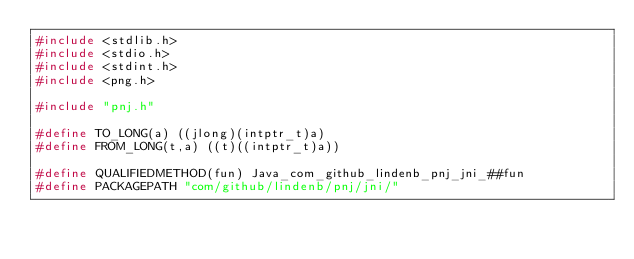Convert code to text. <code><loc_0><loc_0><loc_500><loc_500><_C_>#include <stdlib.h>
#include <stdio.h>
#include <stdint.h>
#include <png.h>

#include "pnj.h"

#define TO_LONG(a) ((jlong)(intptr_t)a)
#define FROM_LONG(t,a) ((t)((intptr_t)a)) 

#define QUALIFIEDMETHOD(fun) Java_com_github_lindenb_pnj_jni_##fun
#define PACKAGEPATH "com/github/lindenb/pnj/jni/"

</code> 